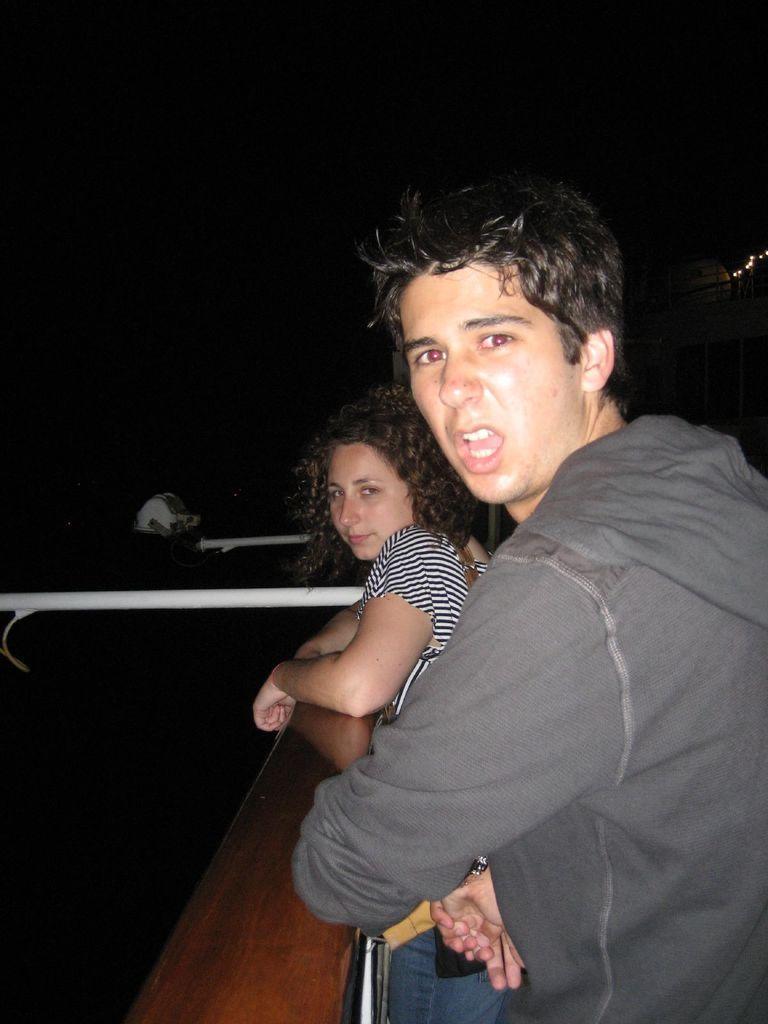Please provide a concise description of this image. In this image a man is standing, he wore sweater. Beside him a beautiful woman is also standing, she wore black and white lines t-shirt. In the middle there are iron rods in white color. 